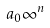Convert formula to latex. <formula><loc_0><loc_0><loc_500><loc_500>a _ { 0 } \infty ^ { n }</formula> 